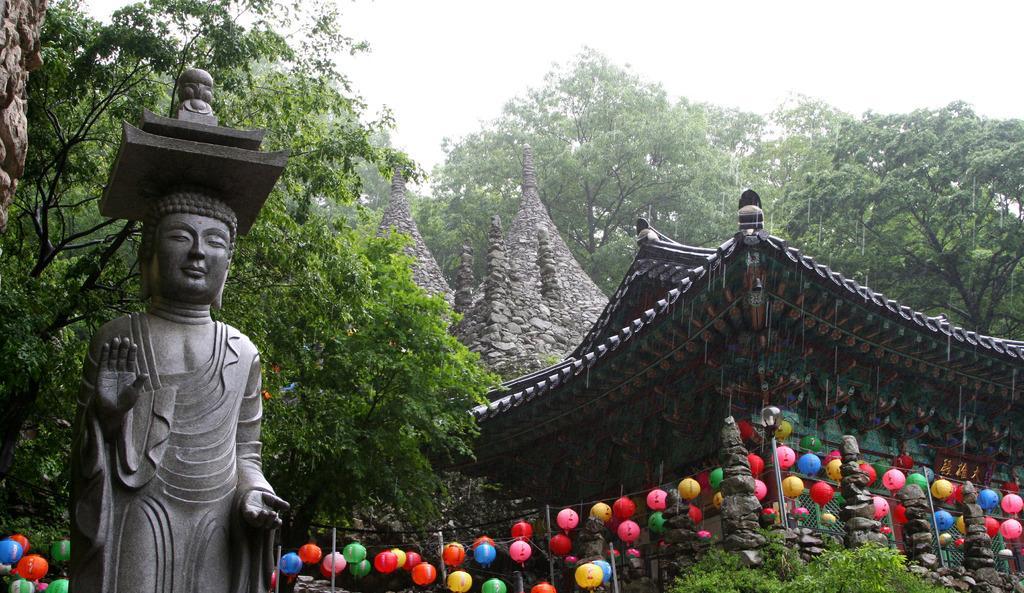Describe this image in one or two sentences. On the left there is a buddha sculpture and there are trees. In the center of the picture there are balloon like decorative items and there is a temple. In the background there are trees. Sky is cloudy. 